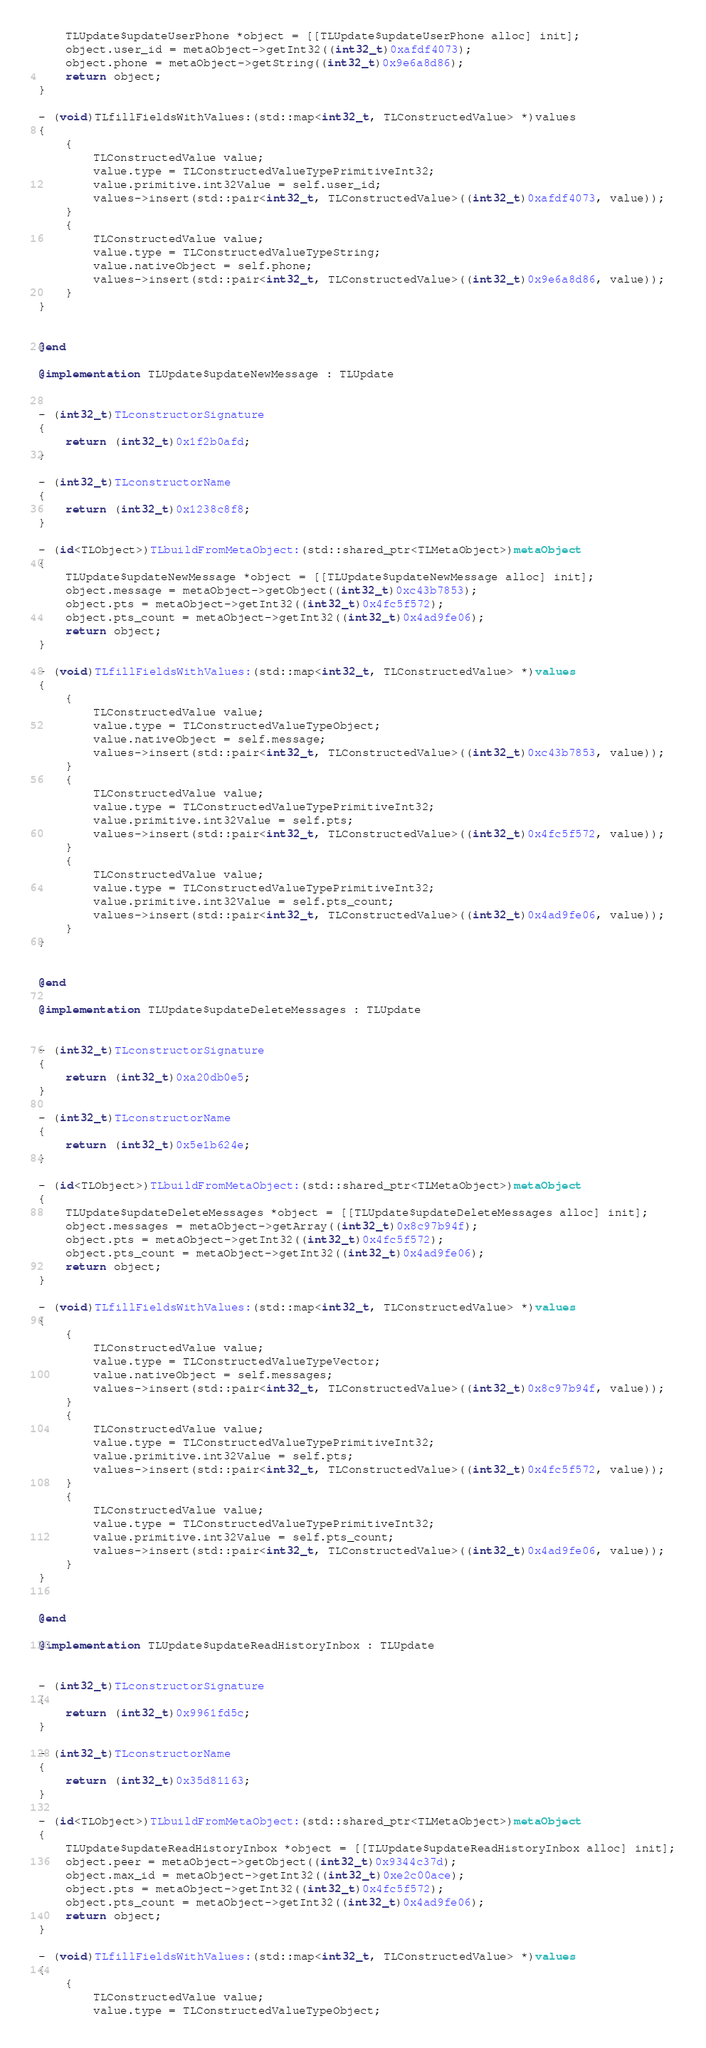<code> <loc_0><loc_0><loc_500><loc_500><_ObjectiveC_>    TLUpdate$updateUserPhone *object = [[TLUpdate$updateUserPhone alloc] init];
    object.user_id = metaObject->getInt32((int32_t)0xafdf4073);
    object.phone = metaObject->getString((int32_t)0x9e6a8d86);
    return object;
}

- (void)TLfillFieldsWithValues:(std::map<int32_t, TLConstructedValue> *)values
{
    {
        TLConstructedValue value;
        value.type = TLConstructedValueTypePrimitiveInt32;
        value.primitive.int32Value = self.user_id;
        values->insert(std::pair<int32_t, TLConstructedValue>((int32_t)0xafdf4073, value));
    }
    {
        TLConstructedValue value;
        value.type = TLConstructedValueTypeString;
        value.nativeObject = self.phone;
        values->insert(std::pair<int32_t, TLConstructedValue>((int32_t)0x9e6a8d86, value));
    }
}


@end

@implementation TLUpdate$updateNewMessage : TLUpdate


- (int32_t)TLconstructorSignature
{
    return (int32_t)0x1f2b0afd;
}

- (int32_t)TLconstructorName
{
    return (int32_t)0x1238c8f8;
}

- (id<TLObject>)TLbuildFromMetaObject:(std::shared_ptr<TLMetaObject>)metaObject
{
    TLUpdate$updateNewMessage *object = [[TLUpdate$updateNewMessage alloc] init];
    object.message = metaObject->getObject((int32_t)0xc43b7853);
    object.pts = metaObject->getInt32((int32_t)0x4fc5f572);
    object.pts_count = metaObject->getInt32((int32_t)0x4ad9fe06);
    return object;
}

- (void)TLfillFieldsWithValues:(std::map<int32_t, TLConstructedValue> *)values
{
    {
        TLConstructedValue value;
        value.type = TLConstructedValueTypeObject;
        value.nativeObject = self.message;
        values->insert(std::pair<int32_t, TLConstructedValue>((int32_t)0xc43b7853, value));
    }
    {
        TLConstructedValue value;
        value.type = TLConstructedValueTypePrimitiveInt32;
        value.primitive.int32Value = self.pts;
        values->insert(std::pair<int32_t, TLConstructedValue>((int32_t)0x4fc5f572, value));
    }
    {
        TLConstructedValue value;
        value.type = TLConstructedValueTypePrimitiveInt32;
        value.primitive.int32Value = self.pts_count;
        values->insert(std::pair<int32_t, TLConstructedValue>((int32_t)0x4ad9fe06, value));
    }
}


@end

@implementation TLUpdate$updateDeleteMessages : TLUpdate


- (int32_t)TLconstructorSignature
{
    return (int32_t)0xa20db0e5;
}

- (int32_t)TLconstructorName
{
    return (int32_t)0x5e1b624e;
}

- (id<TLObject>)TLbuildFromMetaObject:(std::shared_ptr<TLMetaObject>)metaObject
{
    TLUpdate$updateDeleteMessages *object = [[TLUpdate$updateDeleteMessages alloc] init];
    object.messages = metaObject->getArray((int32_t)0x8c97b94f);
    object.pts = metaObject->getInt32((int32_t)0x4fc5f572);
    object.pts_count = metaObject->getInt32((int32_t)0x4ad9fe06);
    return object;
}

- (void)TLfillFieldsWithValues:(std::map<int32_t, TLConstructedValue> *)values
{
    {
        TLConstructedValue value;
        value.type = TLConstructedValueTypeVector;
        value.nativeObject = self.messages;
        values->insert(std::pair<int32_t, TLConstructedValue>((int32_t)0x8c97b94f, value));
    }
    {
        TLConstructedValue value;
        value.type = TLConstructedValueTypePrimitiveInt32;
        value.primitive.int32Value = self.pts;
        values->insert(std::pair<int32_t, TLConstructedValue>((int32_t)0x4fc5f572, value));
    }
    {
        TLConstructedValue value;
        value.type = TLConstructedValueTypePrimitiveInt32;
        value.primitive.int32Value = self.pts_count;
        values->insert(std::pair<int32_t, TLConstructedValue>((int32_t)0x4ad9fe06, value));
    }
}


@end

@implementation TLUpdate$updateReadHistoryInbox : TLUpdate


- (int32_t)TLconstructorSignature
{
    return (int32_t)0x9961fd5c;
}

- (int32_t)TLconstructorName
{
    return (int32_t)0x35d81163;
}

- (id<TLObject>)TLbuildFromMetaObject:(std::shared_ptr<TLMetaObject>)metaObject
{
    TLUpdate$updateReadHistoryInbox *object = [[TLUpdate$updateReadHistoryInbox alloc] init];
    object.peer = metaObject->getObject((int32_t)0x9344c37d);
    object.max_id = metaObject->getInt32((int32_t)0xe2c00ace);
    object.pts = metaObject->getInt32((int32_t)0x4fc5f572);
    object.pts_count = metaObject->getInt32((int32_t)0x4ad9fe06);
    return object;
}

- (void)TLfillFieldsWithValues:(std::map<int32_t, TLConstructedValue> *)values
{
    {
        TLConstructedValue value;
        value.type = TLConstructedValueTypeObject;</code> 